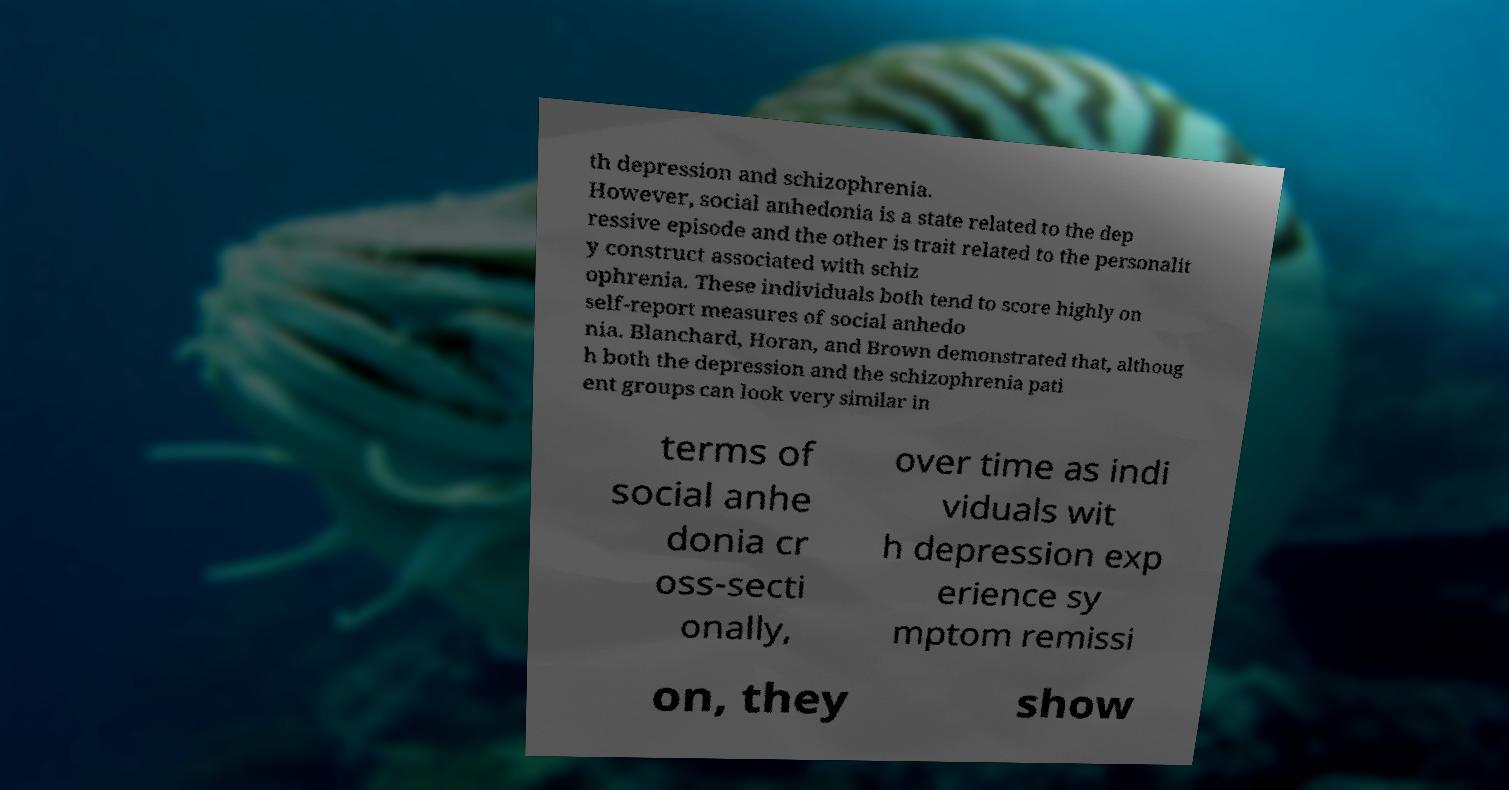Please identify and transcribe the text found in this image. th depression and schizophrenia. However, social anhedonia is a state related to the dep ressive episode and the other is trait related to the personalit y construct associated with schiz ophrenia. These individuals both tend to score highly on self-report measures of social anhedo nia. Blanchard, Horan, and Brown demonstrated that, althoug h both the depression and the schizophrenia pati ent groups can look very similar in terms of social anhe donia cr oss-secti onally, over time as indi viduals wit h depression exp erience sy mptom remissi on, they show 